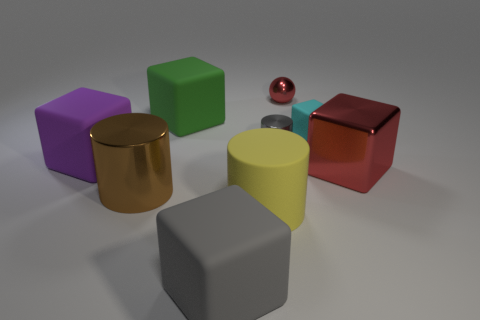Subtract all brown cylinders. How many cylinders are left? 2 Subtract all metal cylinders. How many cylinders are left? 1 Subtract 2 cubes. How many cubes are left? 3 Subtract 1 yellow cylinders. How many objects are left? 8 Subtract all spheres. How many objects are left? 8 Subtract all gray cylinders. Subtract all gray cubes. How many cylinders are left? 2 Subtract all red blocks. How many blue cylinders are left? 0 Subtract all tiny cyan things. Subtract all cyan blocks. How many objects are left? 7 Add 4 green things. How many green things are left? 5 Add 7 big purple balls. How many big purple balls exist? 7 